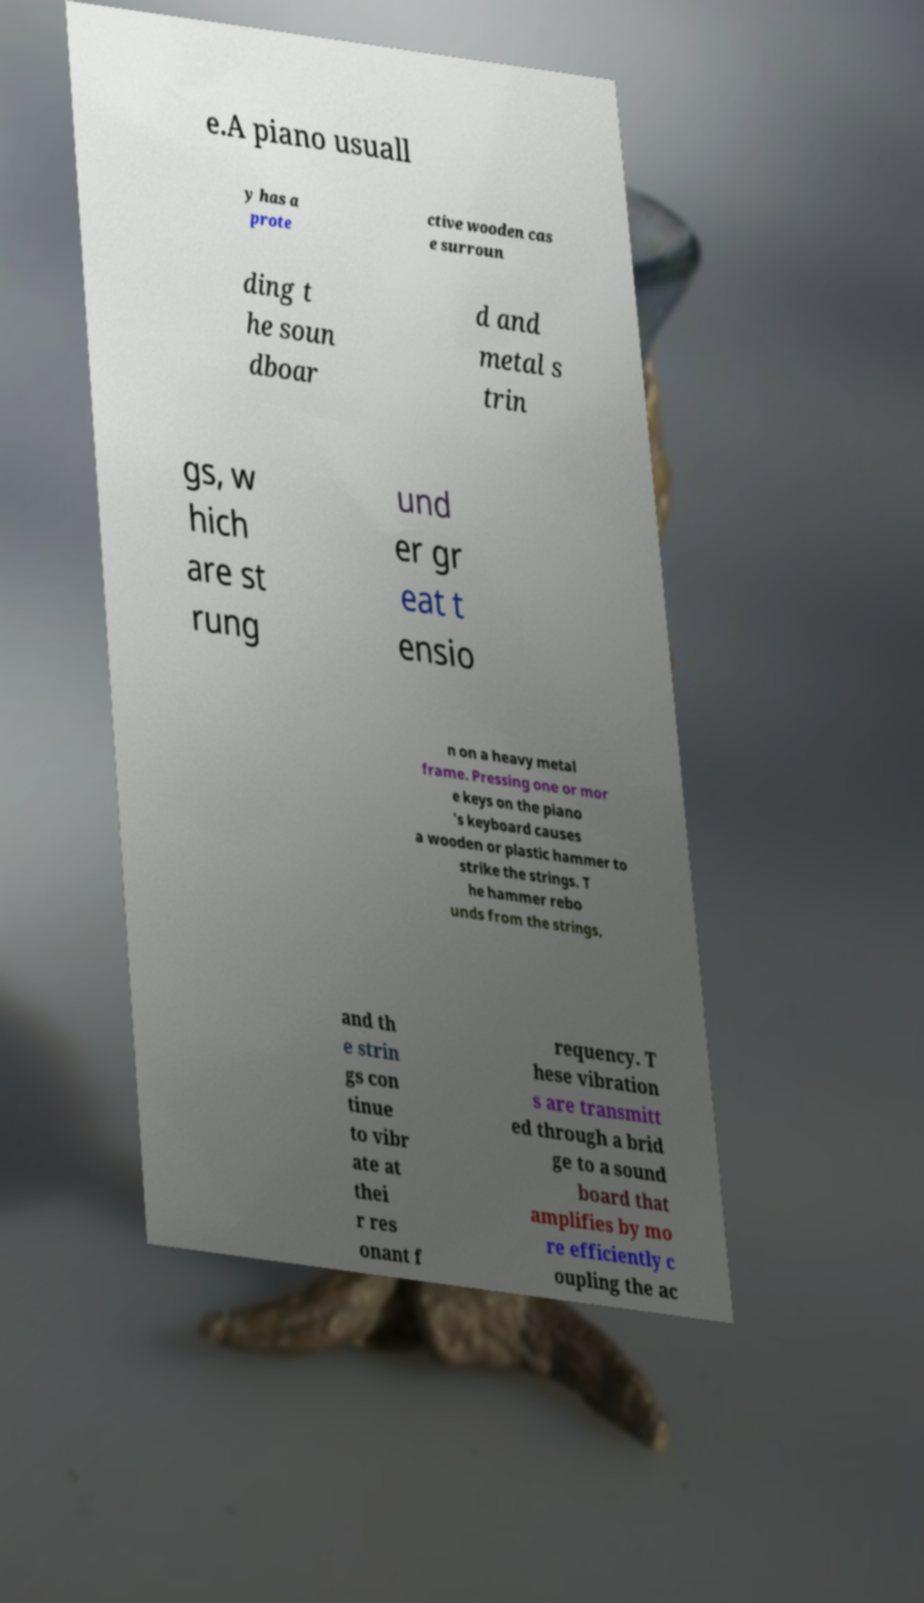Please identify and transcribe the text found in this image. e.A piano usuall y has a prote ctive wooden cas e surroun ding t he soun dboar d and metal s trin gs, w hich are st rung und er gr eat t ensio n on a heavy metal frame. Pressing one or mor e keys on the piano 's keyboard causes a wooden or plastic hammer to strike the strings. T he hammer rebo unds from the strings, and th e strin gs con tinue to vibr ate at thei r res onant f requency. T hese vibration s are transmitt ed through a brid ge to a sound board that amplifies by mo re efficiently c oupling the ac 